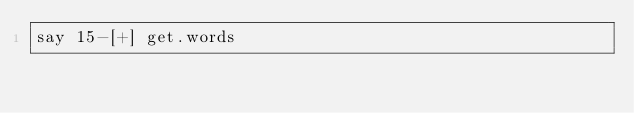Convert code to text. <code><loc_0><loc_0><loc_500><loc_500><_Perl_>say 15-[+] get.words</code> 